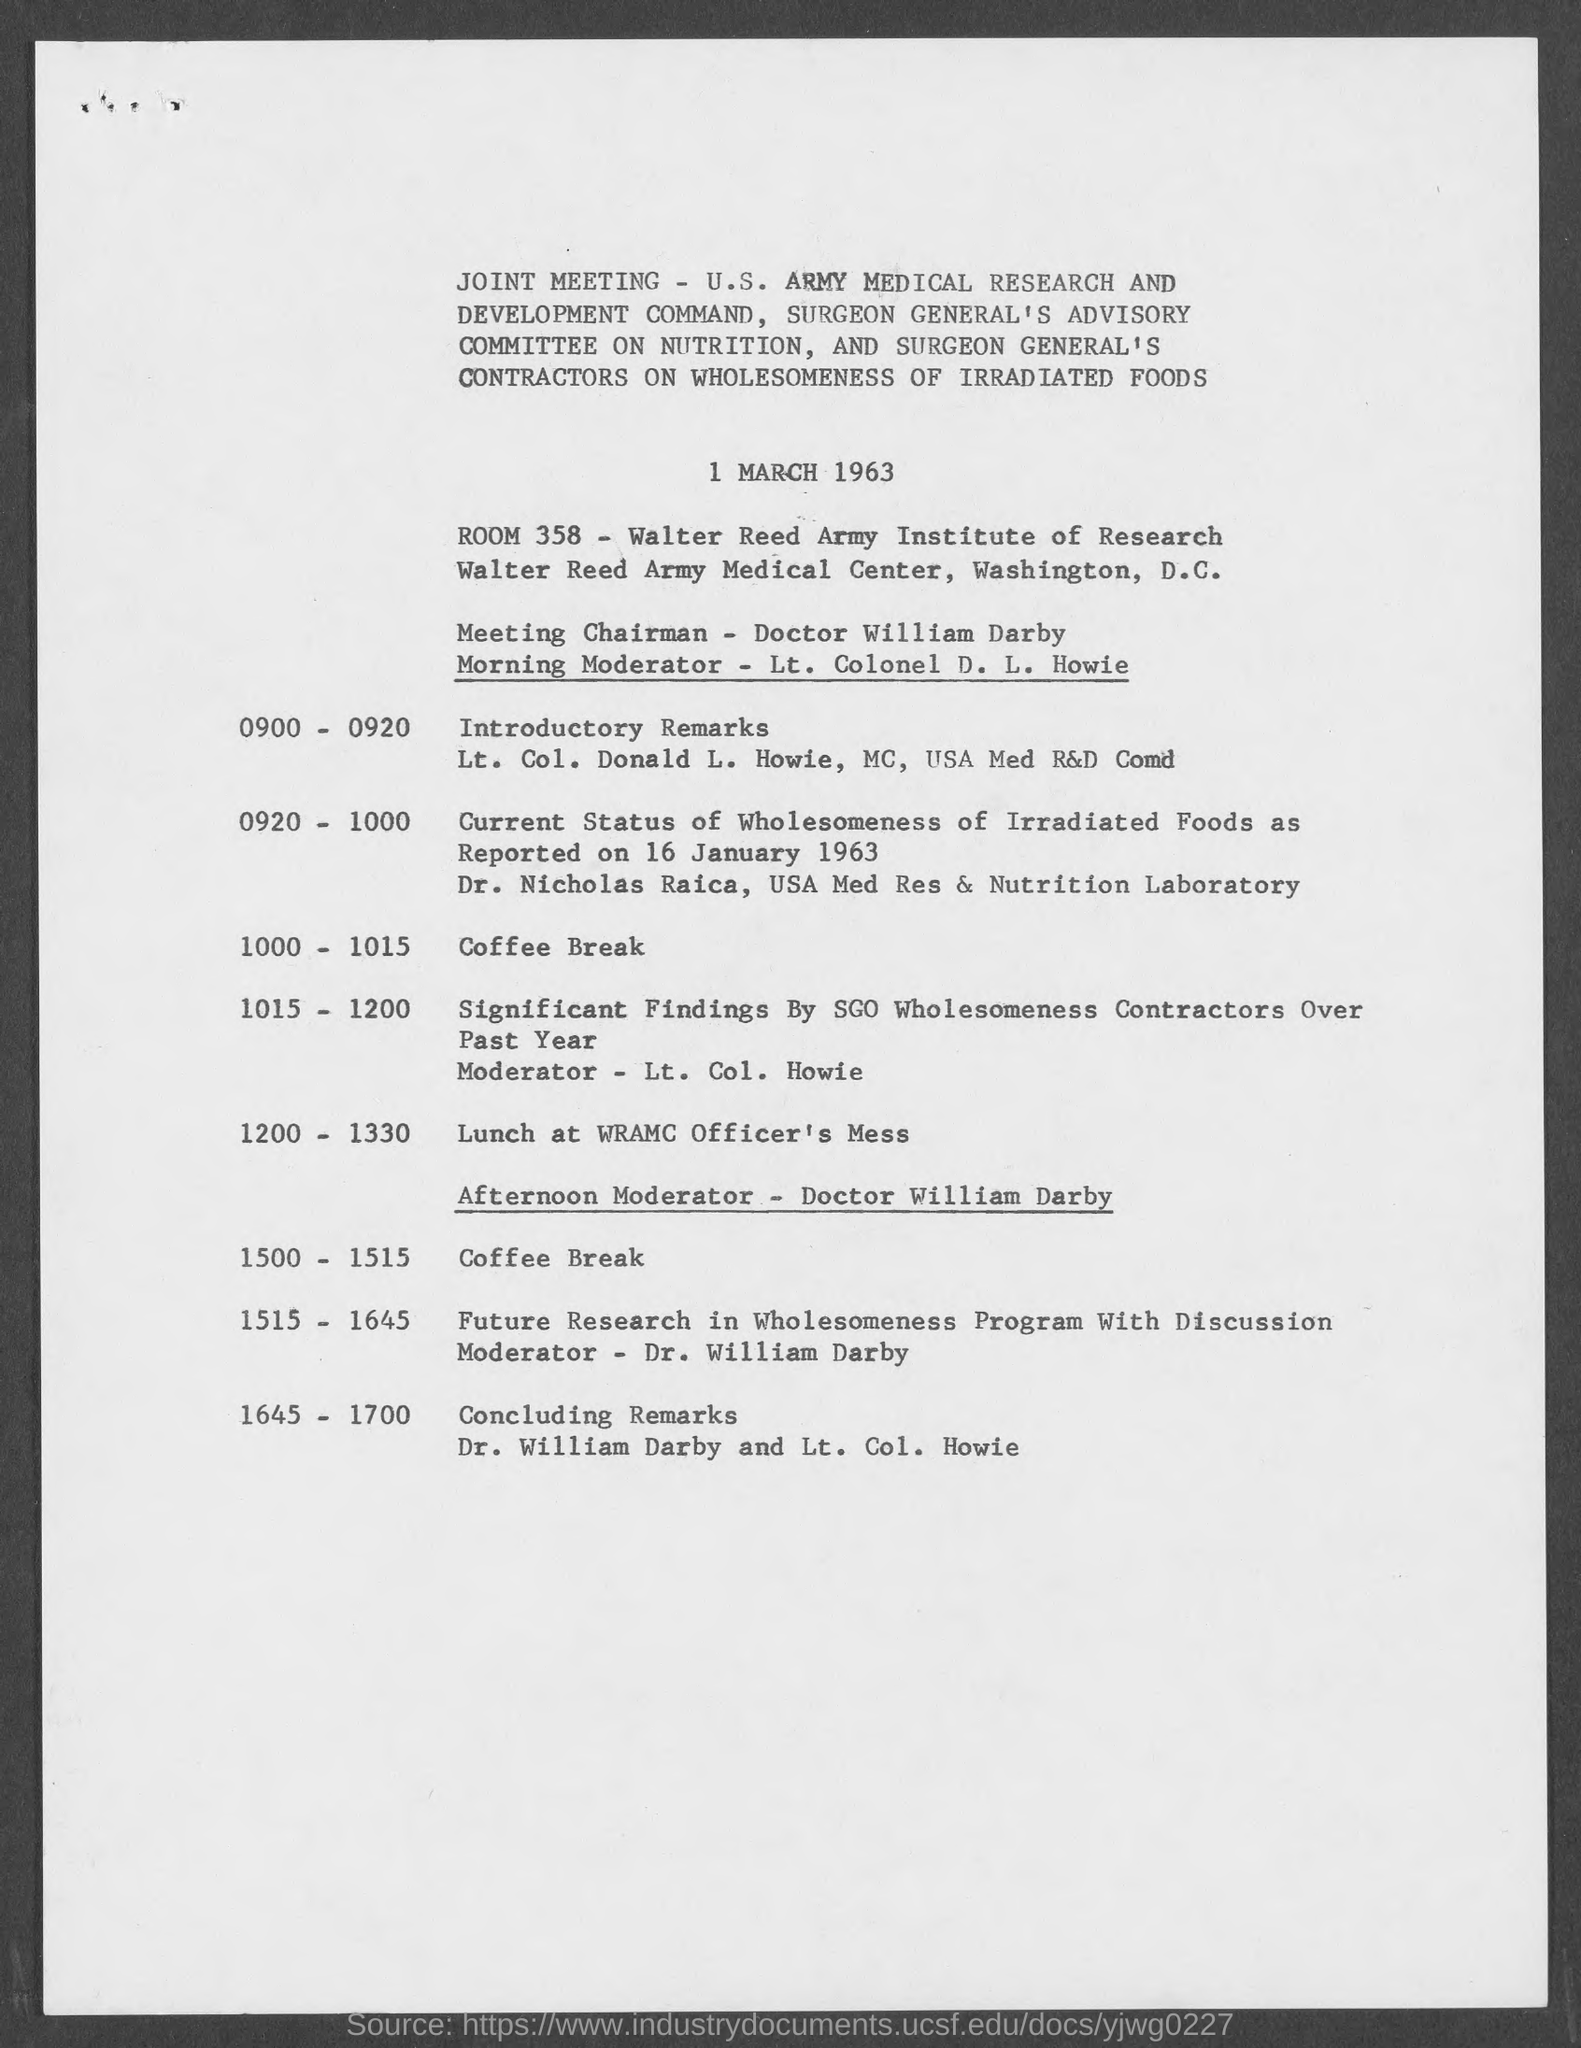Indicate a few pertinent items in this graphic. Dr. William Darby and Lt. Col. Howie are giving the concluding remarks for the meeting. It is announced that Lt. Colonel D. L. Howie will serve as the moderator for the morning sessions. The document indicates that Doctor William Darby is the Meeting Chairman. The joint meeting was held on March 1, 1963, as indicated in the document. The moderator for the afternoon session is Doctor William Darby. 